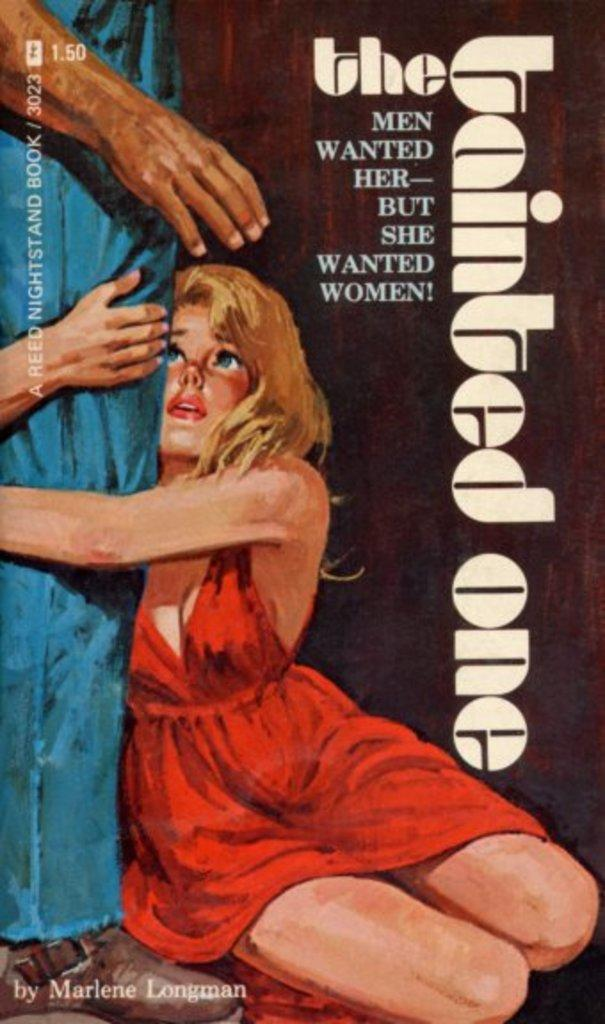<image>
Present a compact description of the photo's key features. A picture of a woman which has the title The Tainted One. 